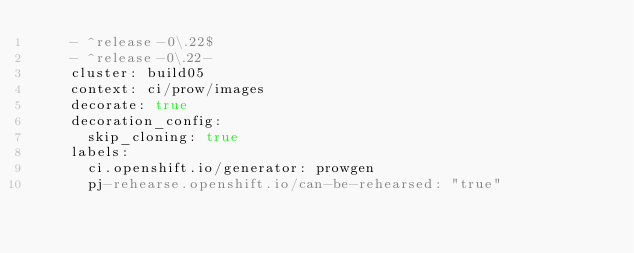<code> <loc_0><loc_0><loc_500><loc_500><_YAML_>    - ^release-0\.22$
    - ^release-0\.22-
    cluster: build05
    context: ci/prow/images
    decorate: true
    decoration_config:
      skip_cloning: true
    labels:
      ci.openshift.io/generator: prowgen
      pj-rehearse.openshift.io/can-be-rehearsed: "true"</code> 